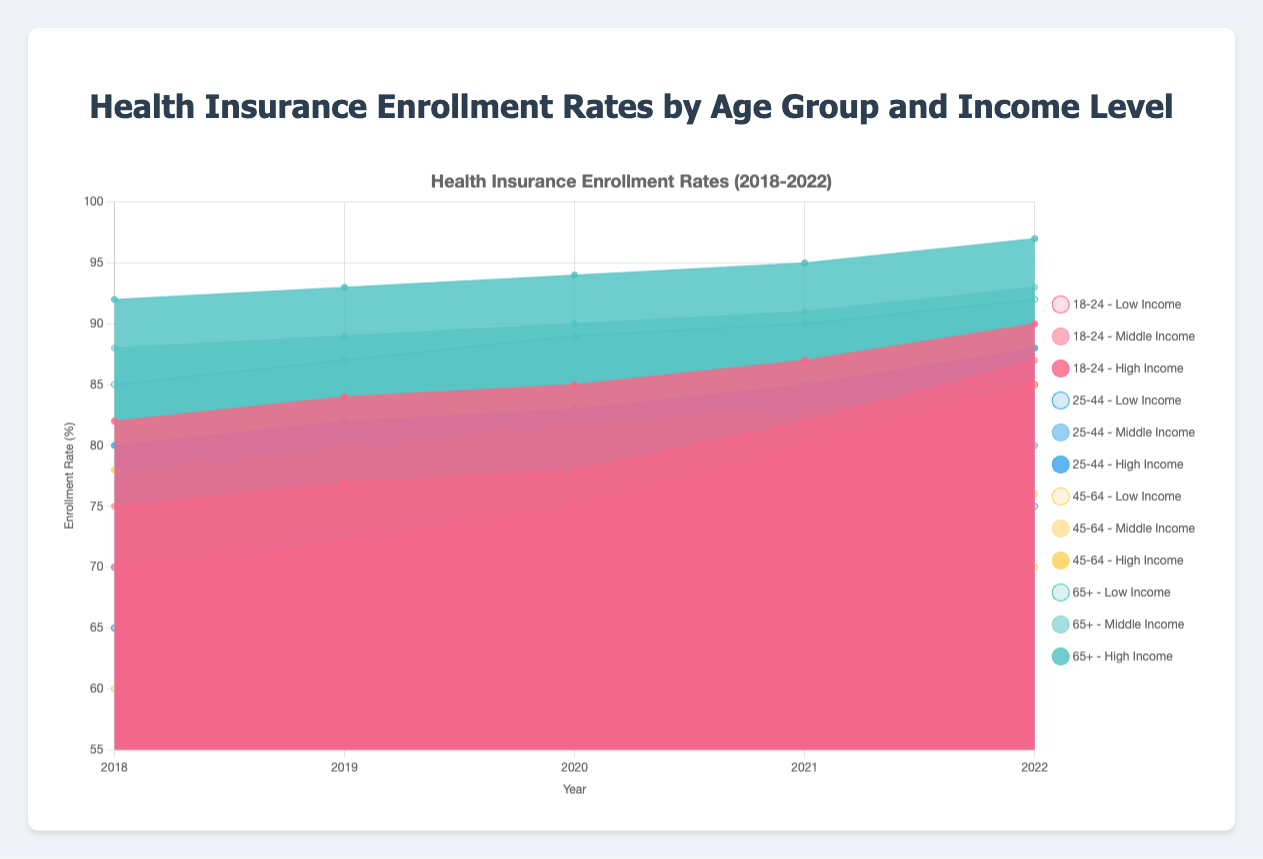What is the title of the figure? The title is shown at the top of the figure. It reads "Health Insurance Enrollment Rates by Age Group and Income Level".
Answer: Health Insurance Enrollment Rates by Age Group and Income Level What are the years displayed on the x-axis? The x-axis displays the years 2018, 2019, 2020, 2021, and 2022. You can see these years labeled at the bottom of the chart.
Answer: 2018, 2019, 2020, 2021, 2022 Which age group had the highest enrollment rate in 2022? Look at the rightmost side of the figure under the year 2022. The age group 65+ has the highest enrollment rates across all income levels compared to other age groups.
Answer: 65+ How did the enrollment rate for low-income individuals aged 18-24 change from 2018 to 2022? First, find the line representing low-income individuals aged 18-24. In 2018 their rate was 70%, and it increased to 85% in 2022, indicating an increase of 15%.
Answer: Increased by 15% Which income group for ages 25-44 had the smallest increase in enrollment rates from 2018 to 2022? Look at the data for the 25-44 age group. The low-income group went from 65% to 75% (10% increase), middle-income from 70% to 80% (10% increase), and high-income from 80% to 88% (8% increase). The high-income group had the smallest increase.
Answer: High Income Among middle-income groups, which age group saw the smallest enrollment improvement from 2018 to 2022? Look at middle-income groups for all age ranges. 18-24 improved from 75% to 87% (12%), 25-44 from 70% to 80% (10%), 45-64 from 65% to 76% (11%), and 65+ from 88% to 93% (5%). The 65+ age group had the smallest improvement.
Answer: 65+ In which year did the enrollment rate for high-income individuals aged 45-64 first reach 80%? Locate the line for high-income individuals aged 45-64, marked by a specific color. Trace it to find where it first hits 80%, which occurs in 2019.
Answer: 2019 What was the difference in enrollment rates for low-income vs. high-income individuals aged 18-24 in 2022? In 2022, the enrollment rate for low-income individuals aged 18-24 was 85%, while it was 90% for high-income individuals. The difference is 90% - 85% = 5%.
Answer: 5% How did the enrollment rates for high-income individuals aged 65+ compare between 2020 and 2022? Look at the high-income 65+ data points for both 2020 and 2022. In 2020, the rate was 94%, and it increased to 97% in 2022. So, the rate increased by 3%.
Answer: Increased by 3% Which age group had the most significant increase in enrollment across all income groups in 2021? Identify the lines for each age group and compare their increments in 2021. The 18-24 age group shows a notable increase across low, middle, and high-income levels in 2021.
Answer: 18-24 